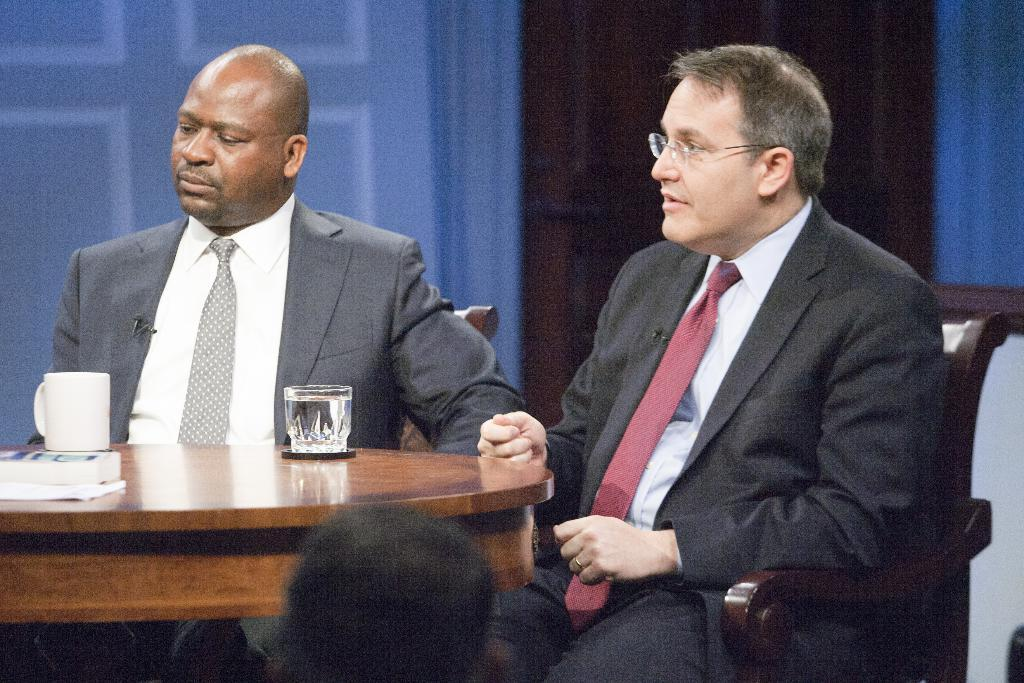How many people are in the image? There are two persons in the image. What are the persons wearing? The persons are wearing suits. What objects can be seen on the table in the image? There is a glass and a coffee cup on the table. What type of destruction can be seen on the shelf in the image? There is no shelf present in the image, and therefore no destruction can be observed. 